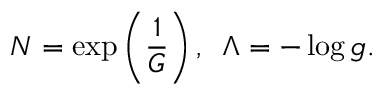Convert formula to latex. <formula><loc_0><loc_0><loc_500><loc_500>N = \exp \left ( \frac { 1 } { G } \right ) , \, \Lambda = - \log g .</formula> 